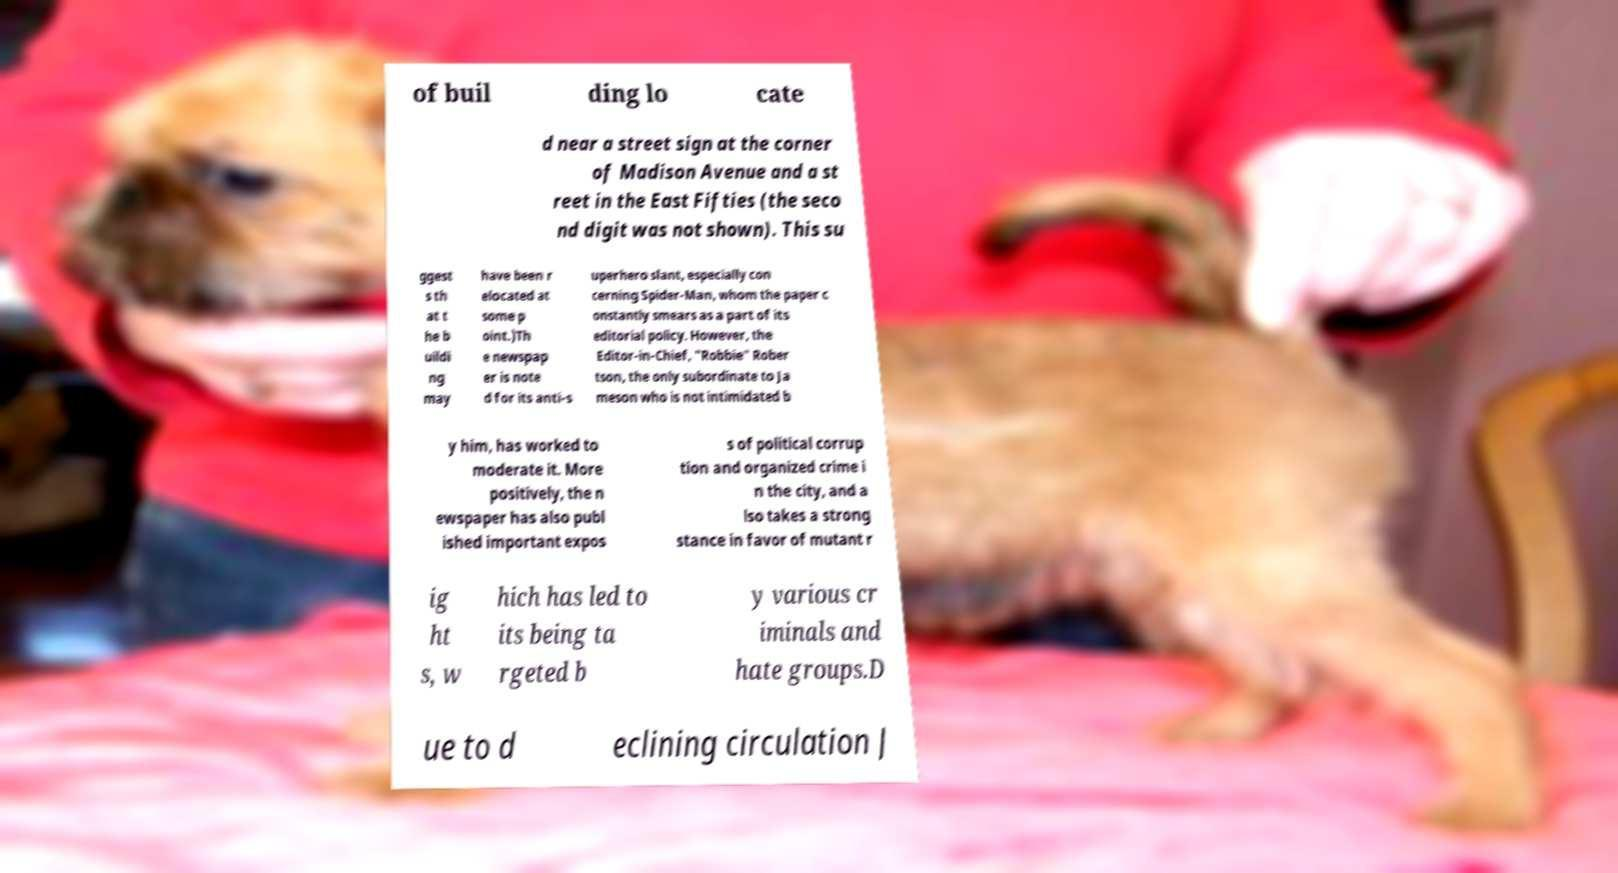What messages or text are displayed in this image? I need them in a readable, typed format. of buil ding lo cate d near a street sign at the corner of Madison Avenue and a st reet in the East Fifties (the seco nd digit was not shown). This su ggest s th at t he b uildi ng may have been r elocated at some p oint.)Th e newspap er is note d for its anti-s uperhero slant, especially con cerning Spider-Man, whom the paper c onstantly smears as a part of its editorial policy. However, the Editor-in-Chief, "Robbie" Rober tson, the only subordinate to Ja meson who is not intimidated b y him, has worked to moderate it. More positively, the n ewspaper has also publ ished important expos s of political corrup tion and organized crime i n the city, and a lso takes a strong stance in favor of mutant r ig ht s, w hich has led to its being ta rgeted b y various cr iminals and hate groups.D ue to d eclining circulation J 